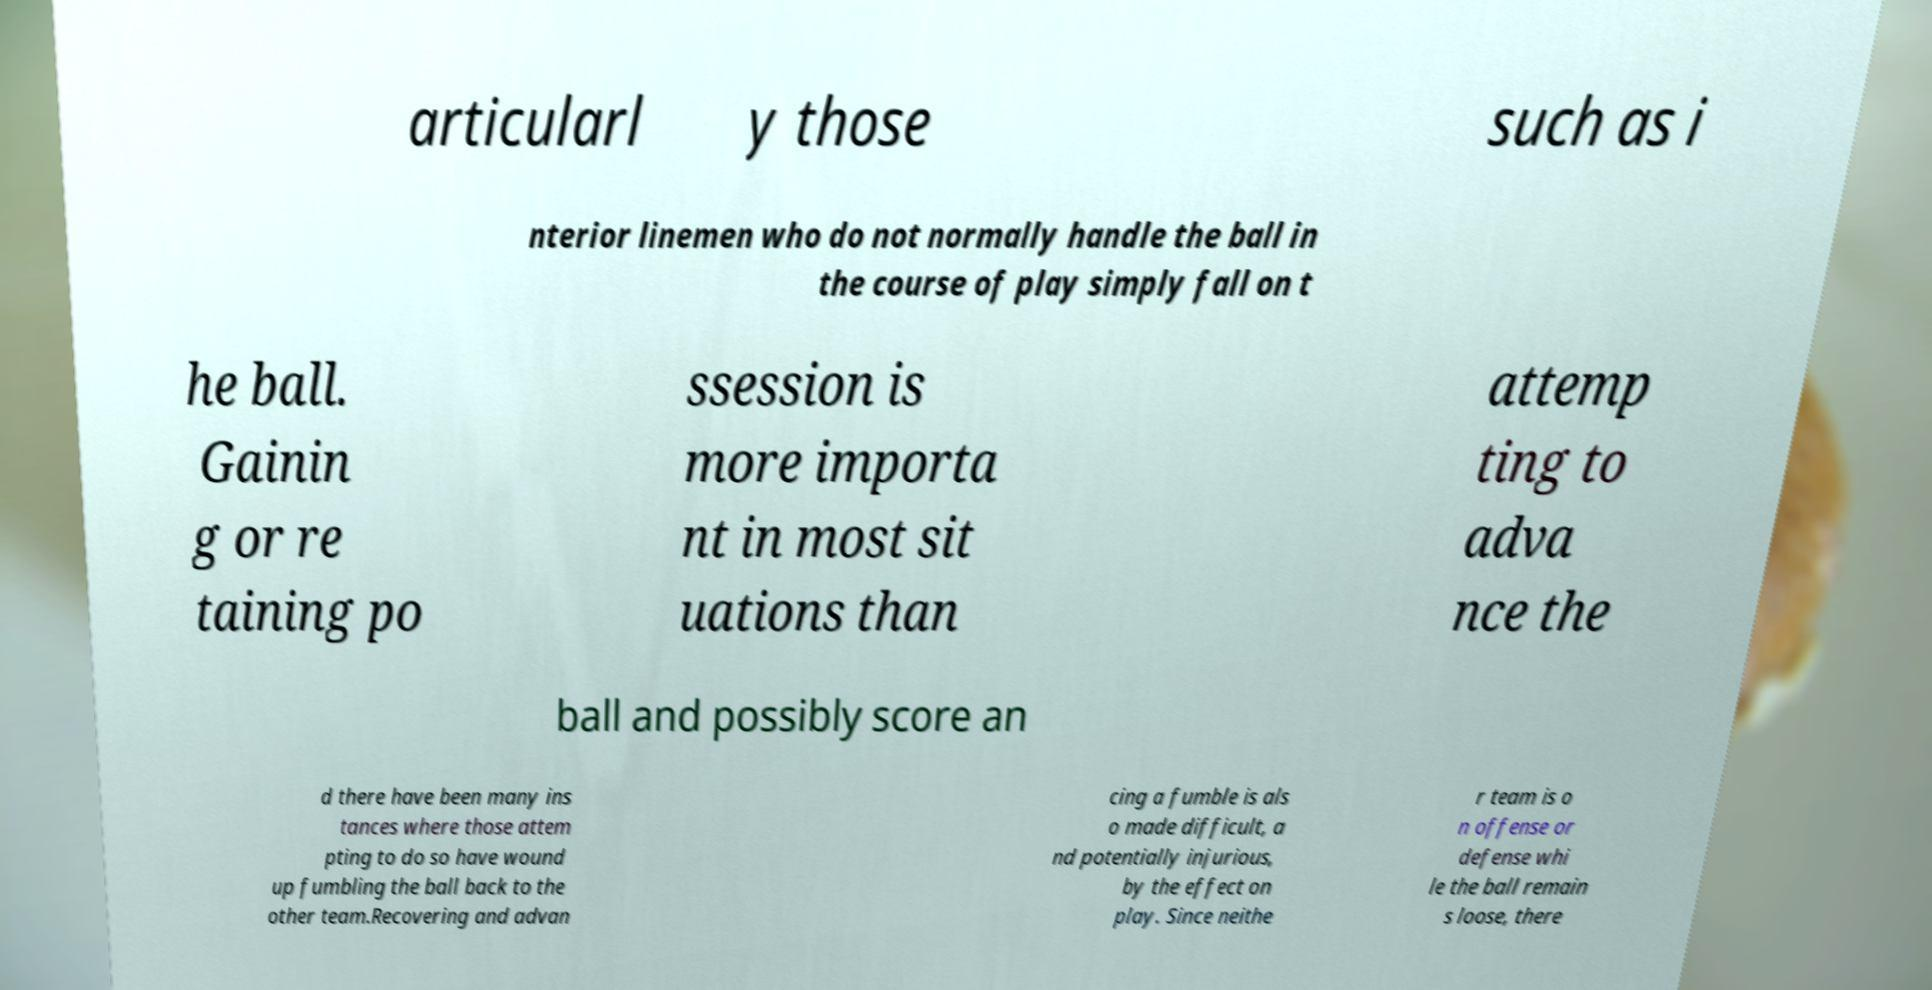There's text embedded in this image that I need extracted. Can you transcribe it verbatim? articularl y those such as i nterior linemen who do not normally handle the ball in the course of play simply fall on t he ball. Gainin g or re taining po ssession is more importa nt in most sit uations than attemp ting to adva nce the ball and possibly score an d there have been many ins tances where those attem pting to do so have wound up fumbling the ball back to the other team.Recovering and advan cing a fumble is als o made difficult, a nd potentially injurious, by the effect on play. Since neithe r team is o n offense or defense whi le the ball remain s loose, there 